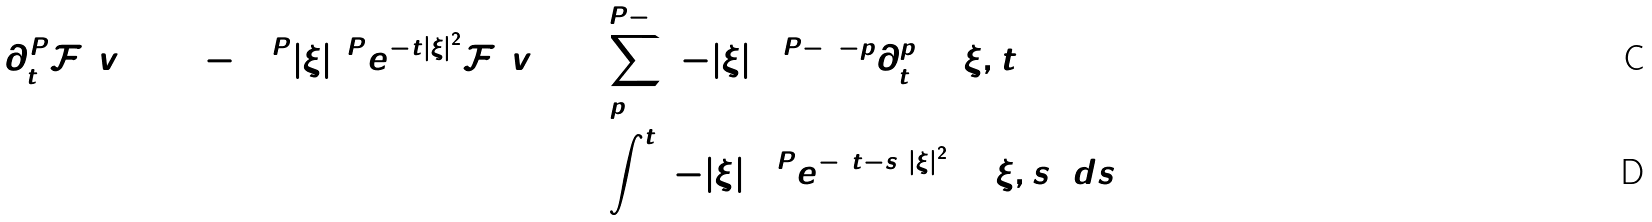Convert formula to latex. <formula><loc_0><loc_0><loc_500><loc_500>\partial ^ { P } _ { t } \mathcal { F } ( v ) = ( - 1 ) ^ { P } | \xi | ^ { 2 P } e ^ { - t | \xi | ^ { 2 } } \mathcal { F } ( v _ { 0 } ) & + \sum _ { p = 0 } ^ { P - 1 } ( - | \xi | ^ { 2 } ) ^ { P - 1 - p } \partial ^ { p } _ { t } \Psi ( \xi , t ) \\ & + \int _ { 0 } ^ { t } ( - | \xi | ^ { 2 } ) ^ { P } e ^ { - ( t - s ) | \xi | ^ { 2 } } \Psi ( \xi , s ) \, d s</formula> 